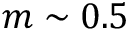<formula> <loc_0><loc_0><loc_500><loc_500>m \sim 0 . 5</formula> 